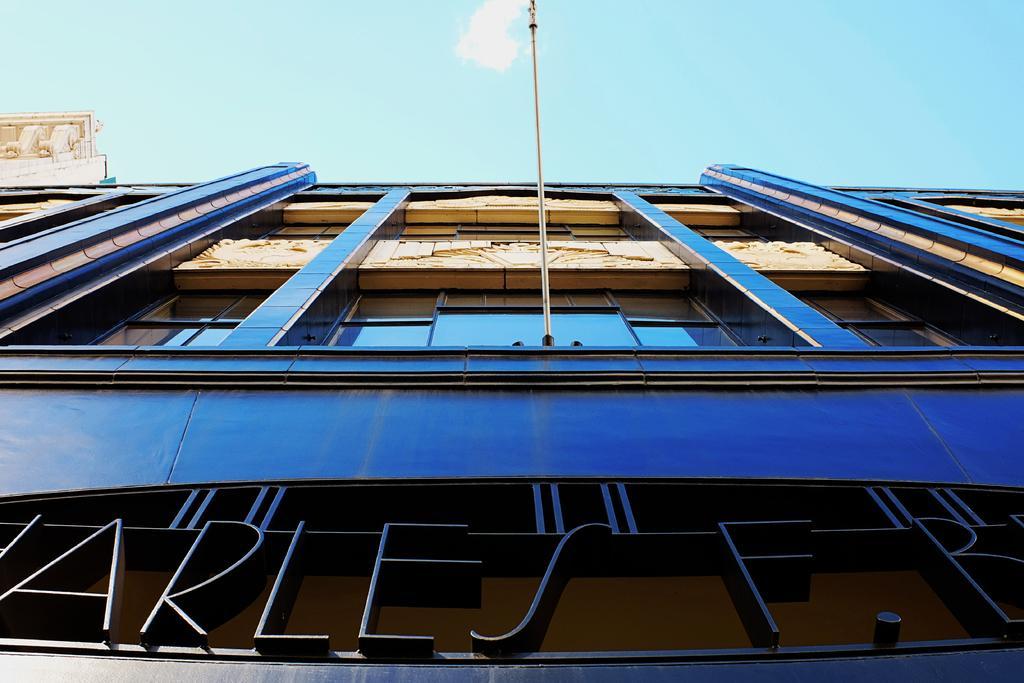Can you describe this image briefly? In this image we can see a building with windows, a pole, sky and we can also see some text written at the bottom. 